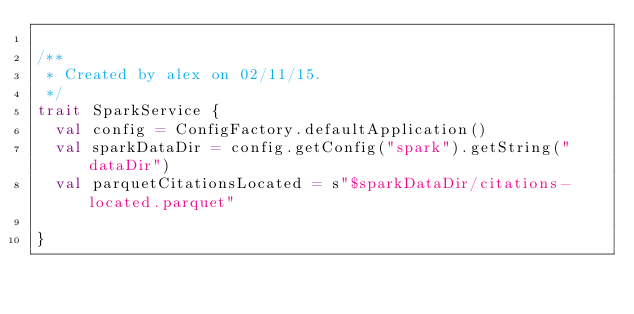Convert code to text. <code><loc_0><loc_0><loc_500><loc_500><_Scala_>
/**
 * Created by alex on 02/11/15.
 */
trait SparkService {
  val config = ConfigFactory.defaultApplication()
  val sparkDataDir = config.getConfig("spark").getString("dataDir")
  val parquetCitationsLocated = s"$sparkDataDir/citations-located.parquet"

}
</code> 